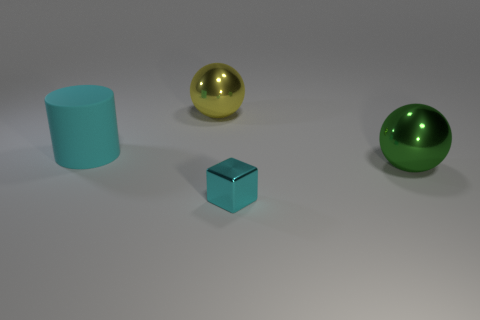Subtract all yellow spheres. How many spheres are left? 1 Subtract all blocks. How many objects are left? 3 Subtract 1 cylinders. How many cylinders are left? 0 Add 1 yellow objects. How many objects exist? 5 Add 1 tiny things. How many tiny things exist? 2 Subtract 0 yellow cylinders. How many objects are left? 4 Subtract all purple cylinders. Subtract all blue balls. How many cylinders are left? 1 Subtract all tiny brown matte cubes. Subtract all cyan shiny things. How many objects are left? 3 Add 4 big green objects. How many big green objects are left? 5 